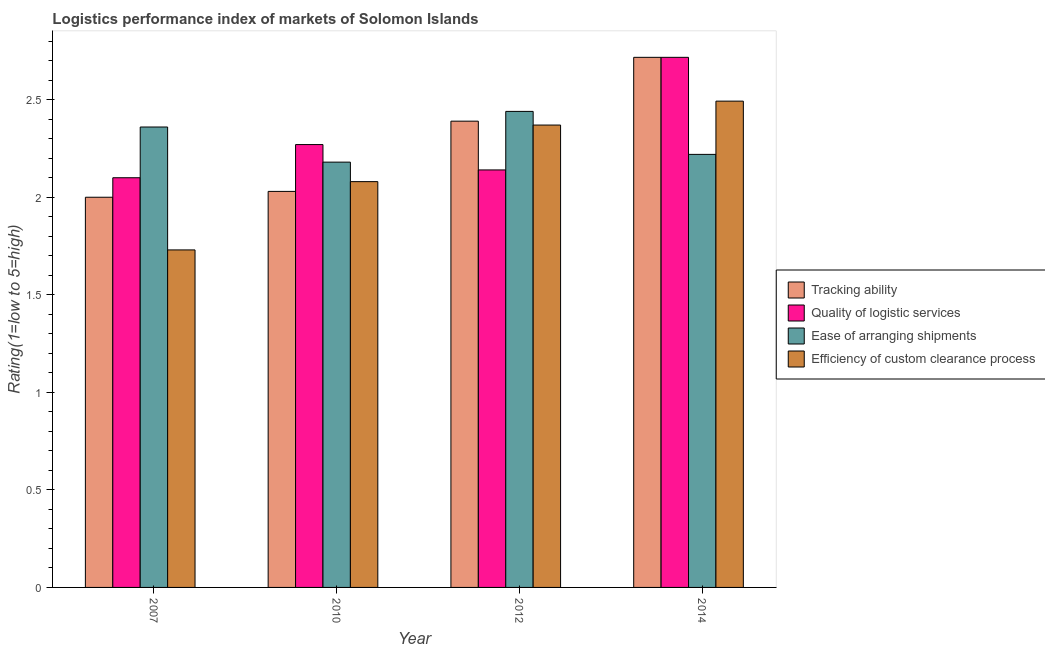How many groups of bars are there?
Give a very brief answer. 4. Are the number of bars per tick equal to the number of legend labels?
Make the answer very short. Yes. Are the number of bars on each tick of the X-axis equal?
Offer a terse response. Yes. How many bars are there on the 4th tick from the left?
Ensure brevity in your answer.  4. What is the label of the 4th group of bars from the left?
Offer a terse response. 2014. In how many cases, is the number of bars for a given year not equal to the number of legend labels?
Give a very brief answer. 0. What is the lpi rating of quality of logistic services in 2014?
Offer a very short reply. 2.72. Across all years, what is the maximum lpi rating of tracking ability?
Your response must be concise. 2.72. Across all years, what is the minimum lpi rating of efficiency of custom clearance process?
Keep it short and to the point. 1.73. In which year was the lpi rating of ease of arranging shipments maximum?
Give a very brief answer. 2012. What is the total lpi rating of tracking ability in the graph?
Keep it short and to the point. 9.14. What is the difference between the lpi rating of ease of arranging shipments in 2007 and that in 2012?
Offer a terse response. -0.08. What is the difference between the lpi rating of quality of logistic services in 2010 and the lpi rating of efficiency of custom clearance process in 2007?
Provide a succinct answer. 0.17. What is the average lpi rating of ease of arranging shipments per year?
Your answer should be compact. 2.3. In the year 2010, what is the difference between the lpi rating of tracking ability and lpi rating of quality of logistic services?
Make the answer very short. 0. In how many years, is the lpi rating of efficiency of custom clearance process greater than 0.2?
Give a very brief answer. 4. What is the ratio of the lpi rating of ease of arranging shipments in 2007 to that in 2010?
Make the answer very short. 1.08. Is the lpi rating of ease of arranging shipments in 2010 less than that in 2012?
Give a very brief answer. Yes. Is the difference between the lpi rating of quality of logistic services in 2010 and 2012 greater than the difference between the lpi rating of tracking ability in 2010 and 2012?
Your answer should be very brief. No. What is the difference between the highest and the second highest lpi rating of ease of arranging shipments?
Provide a short and direct response. 0.08. What is the difference between the highest and the lowest lpi rating of tracking ability?
Offer a terse response. 0.72. Is the sum of the lpi rating of tracking ability in 2007 and 2010 greater than the maximum lpi rating of efficiency of custom clearance process across all years?
Keep it short and to the point. Yes. Is it the case that in every year, the sum of the lpi rating of tracking ability and lpi rating of quality of logistic services is greater than the sum of lpi rating of efficiency of custom clearance process and lpi rating of ease of arranging shipments?
Your response must be concise. No. What does the 3rd bar from the left in 2010 represents?
Your answer should be very brief. Ease of arranging shipments. What does the 2nd bar from the right in 2010 represents?
Make the answer very short. Ease of arranging shipments. How many bars are there?
Your response must be concise. 16. How many years are there in the graph?
Offer a terse response. 4. What is the difference between two consecutive major ticks on the Y-axis?
Give a very brief answer. 0.5. Does the graph contain any zero values?
Ensure brevity in your answer.  No. Does the graph contain grids?
Your answer should be compact. No. What is the title of the graph?
Your answer should be compact. Logistics performance index of markets of Solomon Islands. What is the label or title of the Y-axis?
Offer a terse response. Rating(1=low to 5=high). What is the Rating(1=low to 5=high) in Tracking ability in 2007?
Provide a short and direct response. 2. What is the Rating(1=low to 5=high) in Quality of logistic services in 2007?
Make the answer very short. 2.1. What is the Rating(1=low to 5=high) in Ease of arranging shipments in 2007?
Provide a succinct answer. 2.36. What is the Rating(1=low to 5=high) in Efficiency of custom clearance process in 2007?
Provide a short and direct response. 1.73. What is the Rating(1=low to 5=high) in Tracking ability in 2010?
Your answer should be compact. 2.03. What is the Rating(1=low to 5=high) in Quality of logistic services in 2010?
Offer a terse response. 2.27. What is the Rating(1=low to 5=high) of Ease of arranging shipments in 2010?
Keep it short and to the point. 2.18. What is the Rating(1=low to 5=high) of Efficiency of custom clearance process in 2010?
Your answer should be very brief. 2.08. What is the Rating(1=low to 5=high) of Tracking ability in 2012?
Offer a very short reply. 2.39. What is the Rating(1=low to 5=high) of Quality of logistic services in 2012?
Ensure brevity in your answer.  2.14. What is the Rating(1=low to 5=high) in Ease of arranging shipments in 2012?
Offer a terse response. 2.44. What is the Rating(1=low to 5=high) in Efficiency of custom clearance process in 2012?
Your answer should be very brief. 2.37. What is the Rating(1=low to 5=high) of Tracking ability in 2014?
Keep it short and to the point. 2.72. What is the Rating(1=low to 5=high) of Quality of logistic services in 2014?
Your answer should be compact. 2.72. What is the Rating(1=low to 5=high) in Ease of arranging shipments in 2014?
Your response must be concise. 2.22. What is the Rating(1=low to 5=high) in Efficiency of custom clearance process in 2014?
Provide a succinct answer. 2.49. Across all years, what is the maximum Rating(1=low to 5=high) of Tracking ability?
Your answer should be very brief. 2.72. Across all years, what is the maximum Rating(1=low to 5=high) in Quality of logistic services?
Make the answer very short. 2.72. Across all years, what is the maximum Rating(1=low to 5=high) in Ease of arranging shipments?
Your response must be concise. 2.44. Across all years, what is the maximum Rating(1=low to 5=high) of Efficiency of custom clearance process?
Provide a short and direct response. 2.49. Across all years, what is the minimum Rating(1=low to 5=high) in Tracking ability?
Provide a short and direct response. 2. Across all years, what is the minimum Rating(1=low to 5=high) of Ease of arranging shipments?
Provide a succinct answer. 2.18. Across all years, what is the minimum Rating(1=low to 5=high) in Efficiency of custom clearance process?
Offer a very short reply. 1.73. What is the total Rating(1=low to 5=high) of Tracking ability in the graph?
Your answer should be very brief. 9.14. What is the total Rating(1=low to 5=high) of Quality of logistic services in the graph?
Offer a terse response. 9.23. What is the total Rating(1=low to 5=high) in Ease of arranging shipments in the graph?
Ensure brevity in your answer.  9.2. What is the total Rating(1=low to 5=high) in Efficiency of custom clearance process in the graph?
Ensure brevity in your answer.  8.67. What is the difference between the Rating(1=low to 5=high) of Tracking ability in 2007 and that in 2010?
Offer a very short reply. -0.03. What is the difference between the Rating(1=low to 5=high) of Quality of logistic services in 2007 and that in 2010?
Offer a terse response. -0.17. What is the difference between the Rating(1=low to 5=high) of Ease of arranging shipments in 2007 and that in 2010?
Your response must be concise. 0.18. What is the difference between the Rating(1=low to 5=high) in Efficiency of custom clearance process in 2007 and that in 2010?
Provide a short and direct response. -0.35. What is the difference between the Rating(1=low to 5=high) of Tracking ability in 2007 and that in 2012?
Make the answer very short. -0.39. What is the difference between the Rating(1=low to 5=high) in Quality of logistic services in 2007 and that in 2012?
Your answer should be very brief. -0.04. What is the difference between the Rating(1=low to 5=high) in Ease of arranging shipments in 2007 and that in 2012?
Keep it short and to the point. -0.08. What is the difference between the Rating(1=low to 5=high) of Efficiency of custom clearance process in 2007 and that in 2012?
Offer a very short reply. -0.64. What is the difference between the Rating(1=low to 5=high) in Tracking ability in 2007 and that in 2014?
Your answer should be compact. -0.72. What is the difference between the Rating(1=low to 5=high) of Quality of logistic services in 2007 and that in 2014?
Offer a very short reply. -0.62. What is the difference between the Rating(1=low to 5=high) in Ease of arranging shipments in 2007 and that in 2014?
Keep it short and to the point. 0.14. What is the difference between the Rating(1=low to 5=high) of Efficiency of custom clearance process in 2007 and that in 2014?
Your response must be concise. -0.76. What is the difference between the Rating(1=low to 5=high) of Tracking ability in 2010 and that in 2012?
Keep it short and to the point. -0.36. What is the difference between the Rating(1=low to 5=high) of Quality of logistic services in 2010 and that in 2012?
Your answer should be very brief. 0.13. What is the difference between the Rating(1=low to 5=high) in Ease of arranging shipments in 2010 and that in 2012?
Give a very brief answer. -0.26. What is the difference between the Rating(1=low to 5=high) in Efficiency of custom clearance process in 2010 and that in 2012?
Your answer should be compact. -0.29. What is the difference between the Rating(1=low to 5=high) of Tracking ability in 2010 and that in 2014?
Offer a terse response. -0.69. What is the difference between the Rating(1=low to 5=high) in Quality of logistic services in 2010 and that in 2014?
Make the answer very short. -0.45. What is the difference between the Rating(1=low to 5=high) of Ease of arranging shipments in 2010 and that in 2014?
Keep it short and to the point. -0.04. What is the difference between the Rating(1=low to 5=high) of Efficiency of custom clearance process in 2010 and that in 2014?
Ensure brevity in your answer.  -0.41. What is the difference between the Rating(1=low to 5=high) in Tracking ability in 2012 and that in 2014?
Your response must be concise. -0.33. What is the difference between the Rating(1=low to 5=high) of Quality of logistic services in 2012 and that in 2014?
Keep it short and to the point. -0.58. What is the difference between the Rating(1=low to 5=high) in Ease of arranging shipments in 2012 and that in 2014?
Make the answer very short. 0.22. What is the difference between the Rating(1=low to 5=high) of Efficiency of custom clearance process in 2012 and that in 2014?
Provide a short and direct response. -0.12. What is the difference between the Rating(1=low to 5=high) of Tracking ability in 2007 and the Rating(1=low to 5=high) of Quality of logistic services in 2010?
Offer a terse response. -0.27. What is the difference between the Rating(1=low to 5=high) in Tracking ability in 2007 and the Rating(1=low to 5=high) in Ease of arranging shipments in 2010?
Provide a succinct answer. -0.18. What is the difference between the Rating(1=low to 5=high) of Tracking ability in 2007 and the Rating(1=low to 5=high) of Efficiency of custom clearance process in 2010?
Offer a very short reply. -0.08. What is the difference between the Rating(1=low to 5=high) of Quality of logistic services in 2007 and the Rating(1=low to 5=high) of Ease of arranging shipments in 2010?
Give a very brief answer. -0.08. What is the difference between the Rating(1=low to 5=high) of Ease of arranging shipments in 2007 and the Rating(1=low to 5=high) of Efficiency of custom clearance process in 2010?
Your response must be concise. 0.28. What is the difference between the Rating(1=low to 5=high) in Tracking ability in 2007 and the Rating(1=low to 5=high) in Quality of logistic services in 2012?
Make the answer very short. -0.14. What is the difference between the Rating(1=low to 5=high) of Tracking ability in 2007 and the Rating(1=low to 5=high) of Ease of arranging shipments in 2012?
Make the answer very short. -0.44. What is the difference between the Rating(1=low to 5=high) of Tracking ability in 2007 and the Rating(1=low to 5=high) of Efficiency of custom clearance process in 2012?
Keep it short and to the point. -0.37. What is the difference between the Rating(1=low to 5=high) in Quality of logistic services in 2007 and the Rating(1=low to 5=high) in Ease of arranging shipments in 2012?
Give a very brief answer. -0.34. What is the difference between the Rating(1=low to 5=high) in Quality of logistic services in 2007 and the Rating(1=low to 5=high) in Efficiency of custom clearance process in 2012?
Ensure brevity in your answer.  -0.27. What is the difference between the Rating(1=low to 5=high) of Ease of arranging shipments in 2007 and the Rating(1=low to 5=high) of Efficiency of custom clearance process in 2012?
Your answer should be very brief. -0.01. What is the difference between the Rating(1=low to 5=high) of Tracking ability in 2007 and the Rating(1=low to 5=high) of Quality of logistic services in 2014?
Ensure brevity in your answer.  -0.72. What is the difference between the Rating(1=low to 5=high) of Tracking ability in 2007 and the Rating(1=low to 5=high) of Ease of arranging shipments in 2014?
Your answer should be compact. -0.22. What is the difference between the Rating(1=low to 5=high) in Tracking ability in 2007 and the Rating(1=low to 5=high) in Efficiency of custom clearance process in 2014?
Offer a terse response. -0.49. What is the difference between the Rating(1=low to 5=high) in Quality of logistic services in 2007 and the Rating(1=low to 5=high) in Ease of arranging shipments in 2014?
Offer a very short reply. -0.12. What is the difference between the Rating(1=low to 5=high) in Quality of logistic services in 2007 and the Rating(1=low to 5=high) in Efficiency of custom clearance process in 2014?
Your answer should be compact. -0.39. What is the difference between the Rating(1=low to 5=high) in Ease of arranging shipments in 2007 and the Rating(1=low to 5=high) in Efficiency of custom clearance process in 2014?
Give a very brief answer. -0.13. What is the difference between the Rating(1=low to 5=high) in Tracking ability in 2010 and the Rating(1=low to 5=high) in Quality of logistic services in 2012?
Provide a short and direct response. -0.11. What is the difference between the Rating(1=low to 5=high) of Tracking ability in 2010 and the Rating(1=low to 5=high) of Ease of arranging shipments in 2012?
Make the answer very short. -0.41. What is the difference between the Rating(1=low to 5=high) of Tracking ability in 2010 and the Rating(1=low to 5=high) of Efficiency of custom clearance process in 2012?
Your response must be concise. -0.34. What is the difference between the Rating(1=low to 5=high) in Quality of logistic services in 2010 and the Rating(1=low to 5=high) in Ease of arranging shipments in 2012?
Offer a very short reply. -0.17. What is the difference between the Rating(1=low to 5=high) in Quality of logistic services in 2010 and the Rating(1=low to 5=high) in Efficiency of custom clearance process in 2012?
Your answer should be very brief. -0.1. What is the difference between the Rating(1=low to 5=high) of Ease of arranging shipments in 2010 and the Rating(1=low to 5=high) of Efficiency of custom clearance process in 2012?
Your answer should be very brief. -0.19. What is the difference between the Rating(1=low to 5=high) of Tracking ability in 2010 and the Rating(1=low to 5=high) of Quality of logistic services in 2014?
Ensure brevity in your answer.  -0.69. What is the difference between the Rating(1=low to 5=high) in Tracking ability in 2010 and the Rating(1=low to 5=high) in Ease of arranging shipments in 2014?
Your answer should be compact. -0.19. What is the difference between the Rating(1=low to 5=high) of Tracking ability in 2010 and the Rating(1=low to 5=high) of Efficiency of custom clearance process in 2014?
Ensure brevity in your answer.  -0.46. What is the difference between the Rating(1=low to 5=high) of Quality of logistic services in 2010 and the Rating(1=low to 5=high) of Ease of arranging shipments in 2014?
Keep it short and to the point. 0.05. What is the difference between the Rating(1=low to 5=high) of Quality of logistic services in 2010 and the Rating(1=low to 5=high) of Efficiency of custom clearance process in 2014?
Provide a succinct answer. -0.22. What is the difference between the Rating(1=low to 5=high) of Ease of arranging shipments in 2010 and the Rating(1=low to 5=high) of Efficiency of custom clearance process in 2014?
Your answer should be very brief. -0.31. What is the difference between the Rating(1=low to 5=high) in Tracking ability in 2012 and the Rating(1=low to 5=high) in Quality of logistic services in 2014?
Give a very brief answer. -0.33. What is the difference between the Rating(1=low to 5=high) of Tracking ability in 2012 and the Rating(1=low to 5=high) of Ease of arranging shipments in 2014?
Keep it short and to the point. 0.17. What is the difference between the Rating(1=low to 5=high) in Tracking ability in 2012 and the Rating(1=low to 5=high) in Efficiency of custom clearance process in 2014?
Offer a very short reply. -0.1. What is the difference between the Rating(1=low to 5=high) in Quality of logistic services in 2012 and the Rating(1=low to 5=high) in Ease of arranging shipments in 2014?
Your response must be concise. -0.08. What is the difference between the Rating(1=low to 5=high) of Quality of logistic services in 2012 and the Rating(1=low to 5=high) of Efficiency of custom clearance process in 2014?
Keep it short and to the point. -0.35. What is the difference between the Rating(1=low to 5=high) of Ease of arranging shipments in 2012 and the Rating(1=low to 5=high) of Efficiency of custom clearance process in 2014?
Your answer should be compact. -0.05. What is the average Rating(1=low to 5=high) in Tracking ability per year?
Your answer should be compact. 2.28. What is the average Rating(1=low to 5=high) in Quality of logistic services per year?
Make the answer very short. 2.31. What is the average Rating(1=low to 5=high) of Ease of arranging shipments per year?
Provide a succinct answer. 2.3. What is the average Rating(1=low to 5=high) in Efficiency of custom clearance process per year?
Give a very brief answer. 2.17. In the year 2007, what is the difference between the Rating(1=low to 5=high) of Tracking ability and Rating(1=low to 5=high) of Ease of arranging shipments?
Make the answer very short. -0.36. In the year 2007, what is the difference between the Rating(1=low to 5=high) in Tracking ability and Rating(1=low to 5=high) in Efficiency of custom clearance process?
Your response must be concise. 0.27. In the year 2007, what is the difference between the Rating(1=low to 5=high) in Quality of logistic services and Rating(1=low to 5=high) in Ease of arranging shipments?
Offer a terse response. -0.26. In the year 2007, what is the difference between the Rating(1=low to 5=high) of Quality of logistic services and Rating(1=low to 5=high) of Efficiency of custom clearance process?
Keep it short and to the point. 0.37. In the year 2007, what is the difference between the Rating(1=low to 5=high) in Ease of arranging shipments and Rating(1=low to 5=high) in Efficiency of custom clearance process?
Offer a very short reply. 0.63. In the year 2010, what is the difference between the Rating(1=low to 5=high) of Tracking ability and Rating(1=low to 5=high) of Quality of logistic services?
Offer a terse response. -0.24. In the year 2010, what is the difference between the Rating(1=low to 5=high) in Tracking ability and Rating(1=low to 5=high) in Ease of arranging shipments?
Keep it short and to the point. -0.15. In the year 2010, what is the difference between the Rating(1=low to 5=high) of Tracking ability and Rating(1=low to 5=high) of Efficiency of custom clearance process?
Your answer should be very brief. -0.05. In the year 2010, what is the difference between the Rating(1=low to 5=high) in Quality of logistic services and Rating(1=low to 5=high) in Ease of arranging shipments?
Your response must be concise. 0.09. In the year 2010, what is the difference between the Rating(1=low to 5=high) in Quality of logistic services and Rating(1=low to 5=high) in Efficiency of custom clearance process?
Make the answer very short. 0.19. In the year 2012, what is the difference between the Rating(1=low to 5=high) of Tracking ability and Rating(1=low to 5=high) of Quality of logistic services?
Your answer should be compact. 0.25. In the year 2012, what is the difference between the Rating(1=low to 5=high) of Tracking ability and Rating(1=low to 5=high) of Ease of arranging shipments?
Your answer should be compact. -0.05. In the year 2012, what is the difference between the Rating(1=low to 5=high) in Quality of logistic services and Rating(1=low to 5=high) in Efficiency of custom clearance process?
Give a very brief answer. -0.23. In the year 2012, what is the difference between the Rating(1=low to 5=high) in Ease of arranging shipments and Rating(1=low to 5=high) in Efficiency of custom clearance process?
Make the answer very short. 0.07. In the year 2014, what is the difference between the Rating(1=low to 5=high) of Tracking ability and Rating(1=low to 5=high) of Ease of arranging shipments?
Offer a very short reply. 0.5. In the year 2014, what is the difference between the Rating(1=low to 5=high) of Tracking ability and Rating(1=low to 5=high) of Efficiency of custom clearance process?
Provide a short and direct response. 0.22. In the year 2014, what is the difference between the Rating(1=low to 5=high) in Quality of logistic services and Rating(1=low to 5=high) in Ease of arranging shipments?
Your response must be concise. 0.5. In the year 2014, what is the difference between the Rating(1=low to 5=high) in Quality of logistic services and Rating(1=low to 5=high) in Efficiency of custom clearance process?
Give a very brief answer. 0.22. In the year 2014, what is the difference between the Rating(1=low to 5=high) in Ease of arranging shipments and Rating(1=low to 5=high) in Efficiency of custom clearance process?
Offer a very short reply. -0.27. What is the ratio of the Rating(1=low to 5=high) of Tracking ability in 2007 to that in 2010?
Your answer should be compact. 0.99. What is the ratio of the Rating(1=low to 5=high) in Quality of logistic services in 2007 to that in 2010?
Offer a very short reply. 0.93. What is the ratio of the Rating(1=low to 5=high) of Ease of arranging shipments in 2007 to that in 2010?
Ensure brevity in your answer.  1.08. What is the ratio of the Rating(1=low to 5=high) in Efficiency of custom clearance process in 2007 to that in 2010?
Provide a short and direct response. 0.83. What is the ratio of the Rating(1=low to 5=high) of Tracking ability in 2007 to that in 2012?
Your response must be concise. 0.84. What is the ratio of the Rating(1=low to 5=high) of Quality of logistic services in 2007 to that in 2012?
Offer a very short reply. 0.98. What is the ratio of the Rating(1=low to 5=high) in Ease of arranging shipments in 2007 to that in 2012?
Offer a very short reply. 0.97. What is the ratio of the Rating(1=low to 5=high) in Efficiency of custom clearance process in 2007 to that in 2012?
Provide a short and direct response. 0.73. What is the ratio of the Rating(1=low to 5=high) in Tracking ability in 2007 to that in 2014?
Keep it short and to the point. 0.74. What is the ratio of the Rating(1=low to 5=high) in Quality of logistic services in 2007 to that in 2014?
Offer a terse response. 0.77. What is the ratio of the Rating(1=low to 5=high) of Ease of arranging shipments in 2007 to that in 2014?
Provide a short and direct response. 1.06. What is the ratio of the Rating(1=low to 5=high) in Efficiency of custom clearance process in 2007 to that in 2014?
Your response must be concise. 0.69. What is the ratio of the Rating(1=low to 5=high) in Tracking ability in 2010 to that in 2012?
Offer a very short reply. 0.85. What is the ratio of the Rating(1=low to 5=high) in Quality of logistic services in 2010 to that in 2012?
Keep it short and to the point. 1.06. What is the ratio of the Rating(1=low to 5=high) in Ease of arranging shipments in 2010 to that in 2012?
Give a very brief answer. 0.89. What is the ratio of the Rating(1=low to 5=high) in Efficiency of custom clearance process in 2010 to that in 2012?
Keep it short and to the point. 0.88. What is the ratio of the Rating(1=low to 5=high) in Tracking ability in 2010 to that in 2014?
Your answer should be very brief. 0.75. What is the ratio of the Rating(1=low to 5=high) in Quality of logistic services in 2010 to that in 2014?
Your response must be concise. 0.84. What is the ratio of the Rating(1=low to 5=high) of Ease of arranging shipments in 2010 to that in 2014?
Offer a terse response. 0.98. What is the ratio of the Rating(1=low to 5=high) in Efficiency of custom clearance process in 2010 to that in 2014?
Make the answer very short. 0.83. What is the ratio of the Rating(1=low to 5=high) in Tracking ability in 2012 to that in 2014?
Your answer should be compact. 0.88. What is the ratio of the Rating(1=low to 5=high) in Quality of logistic services in 2012 to that in 2014?
Your answer should be compact. 0.79. What is the ratio of the Rating(1=low to 5=high) of Ease of arranging shipments in 2012 to that in 2014?
Keep it short and to the point. 1.1. What is the ratio of the Rating(1=low to 5=high) of Efficiency of custom clearance process in 2012 to that in 2014?
Your answer should be compact. 0.95. What is the difference between the highest and the second highest Rating(1=low to 5=high) of Tracking ability?
Keep it short and to the point. 0.33. What is the difference between the highest and the second highest Rating(1=low to 5=high) of Quality of logistic services?
Ensure brevity in your answer.  0.45. What is the difference between the highest and the second highest Rating(1=low to 5=high) of Efficiency of custom clearance process?
Give a very brief answer. 0.12. What is the difference between the highest and the lowest Rating(1=low to 5=high) of Tracking ability?
Provide a short and direct response. 0.72. What is the difference between the highest and the lowest Rating(1=low to 5=high) in Quality of logistic services?
Keep it short and to the point. 0.62. What is the difference between the highest and the lowest Rating(1=low to 5=high) of Ease of arranging shipments?
Your answer should be compact. 0.26. What is the difference between the highest and the lowest Rating(1=low to 5=high) of Efficiency of custom clearance process?
Provide a succinct answer. 0.76. 